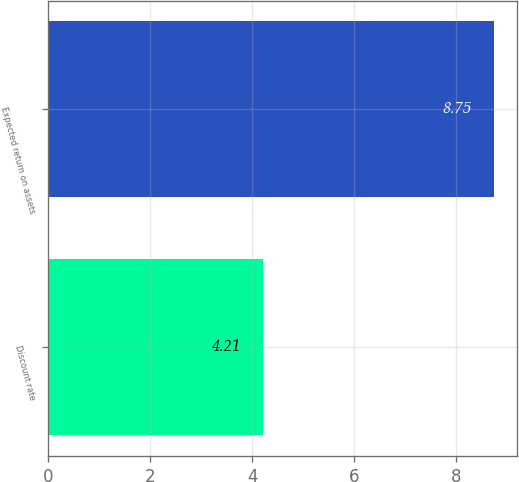<chart> <loc_0><loc_0><loc_500><loc_500><bar_chart><fcel>Discount rate<fcel>Expected return on assets<nl><fcel>4.21<fcel>8.75<nl></chart> 